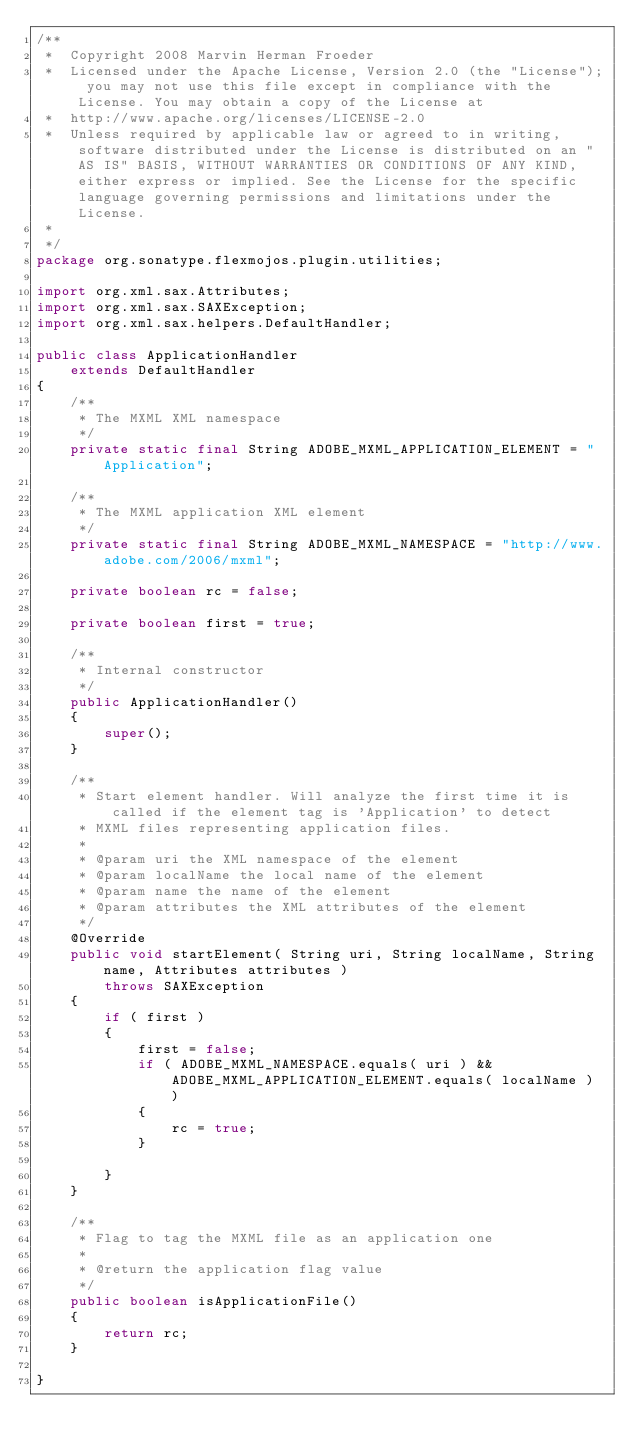<code> <loc_0><loc_0><loc_500><loc_500><_Java_>/**
 *  Copyright 2008 Marvin Herman Froeder
 *  Licensed under the Apache License, Version 2.0 (the "License"); you may not use this file except in compliance with the License. You may obtain a copy of the License at
 *  http://www.apache.org/licenses/LICENSE-2.0
 *  Unless required by applicable law or agreed to in writing, software distributed under the License is distributed on an "AS IS" BASIS, WITHOUT WARRANTIES OR CONDITIONS OF ANY KIND, either express or implied. See the License for the specific language governing permissions and limitations under the License.
 *
 */
package org.sonatype.flexmojos.plugin.utilities;

import org.xml.sax.Attributes;
import org.xml.sax.SAXException;
import org.xml.sax.helpers.DefaultHandler;

public class ApplicationHandler
    extends DefaultHandler
{
    /**
     * The MXML XML namespace
     */
    private static final String ADOBE_MXML_APPLICATION_ELEMENT = "Application";

    /**
     * The MXML application XML element
     */
    private static final String ADOBE_MXML_NAMESPACE = "http://www.adobe.com/2006/mxml";

    private boolean rc = false;

    private boolean first = true;

    /**
     * Internal constructor
     */
    public ApplicationHandler()
    {
        super();
    }

    /**
     * Start element handler. Will analyze the first time it is called if the element tag is 'Application' to detect
     * MXML files representing application files.
     * 
     * @param uri the XML namespace of the element
     * @param localName the local name of the element
     * @param name the name of the element
     * @param attributes the XML attributes of the element
     */
    @Override
    public void startElement( String uri, String localName, String name, Attributes attributes )
        throws SAXException
    {
        if ( first )
        {
            first = false;
            if ( ADOBE_MXML_NAMESPACE.equals( uri ) && ADOBE_MXML_APPLICATION_ELEMENT.equals( localName ) )
            {
                rc = true;
            }

        }
    }

    /**
     * Flag to tag the MXML file as an application one
     * 
     * @return the application flag value
     */
    public boolean isApplicationFile()
    {
        return rc;
    }

}
</code> 